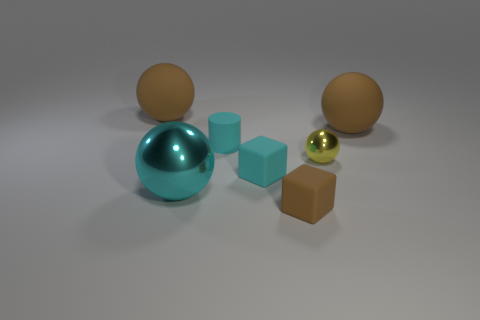Subtract 1 spheres. How many spheres are left? 3 Subtract all green balls. Subtract all purple blocks. How many balls are left? 4 Add 1 brown cubes. How many objects exist? 8 Subtract all balls. How many objects are left? 3 Subtract 1 cyan balls. How many objects are left? 6 Subtract all tiny purple spheres. Subtract all brown matte blocks. How many objects are left? 6 Add 6 big cyan metal spheres. How many big cyan metal spheres are left? 7 Add 7 tiny cubes. How many tiny cubes exist? 9 